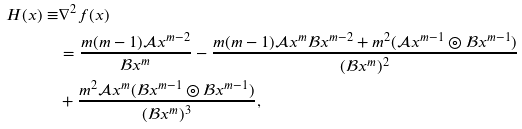Convert formula to latex. <formula><loc_0><loc_0><loc_500><loc_500>H ( x ) \equiv & \nabla ^ { 2 } f ( x ) \\ & = \frac { m ( m - 1 ) \mathcal { A } x ^ { m - 2 } } { \mathcal { B } x ^ { m } } - \frac { m ( m - 1 ) \mathcal { A } x ^ { m } \mathcal { B } x ^ { m - 2 } + m ^ { 2 } ( \mathcal { A } x ^ { m - 1 } \circledcirc \mathcal { B } x ^ { m - 1 } ) } { ( \mathcal { B } x ^ { m } ) ^ { 2 } } \\ & + \frac { m ^ { 2 } \mathcal { A } x ^ { m } ( \mathcal { B } x ^ { m - 1 } \circledcirc \mathcal { B } x ^ { m - 1 } ) } { ( \mathcal { B } x ^ { m } ) ^ { 3 } } ,</formula> 